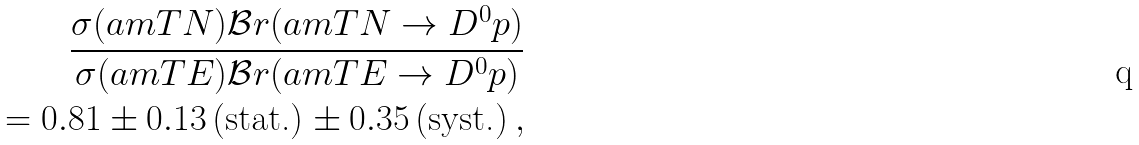<formula> <loc_0><loc_0><loc_500><loc_500>\frac { \sigma ( \L a m T N ) \mathcal { B } r ( \L a m T N \to D ^ { 0 } p ) } { \sigma ( \L a m T E ) \mathcal { B } r ( \L a m T E \to D ^ { 0 } p ) } \\ \quad = 0 . 8 1 \pm 0 . 1 3 \, \text {(stat.)} \pm 0 . 3 5 \, \text {(syst.)} \, ,</formula> 